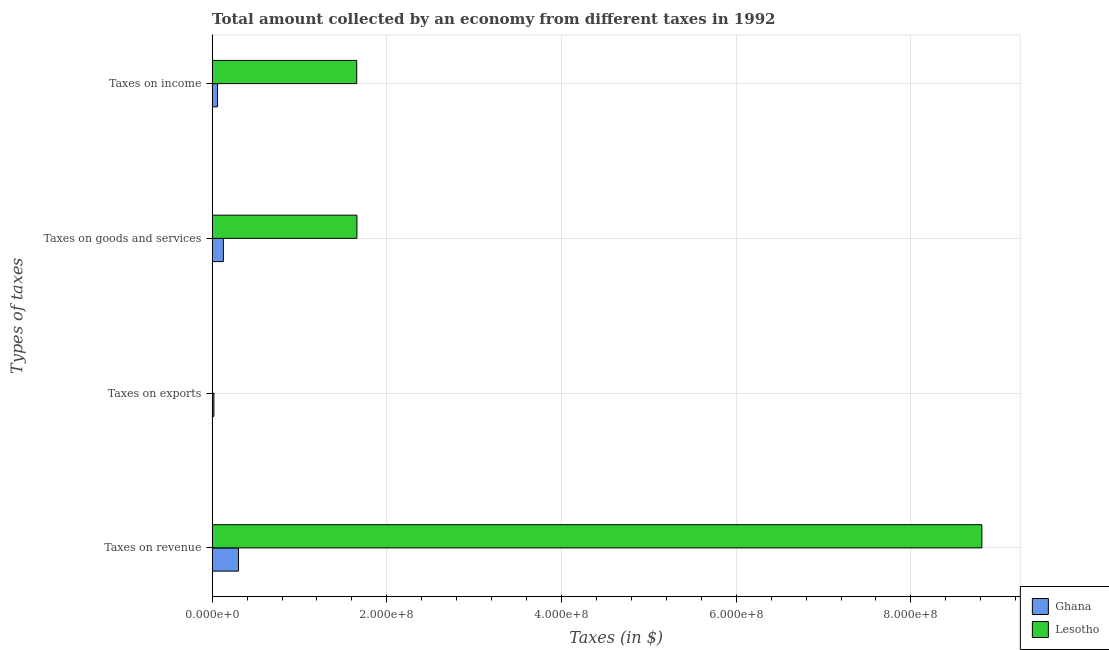How many groups of bars are there?
Your answer should be very brief. 4. Are the number of bars on each tick of the Y-axis equal?
Your answer should be compact. Yes. How many bars are there on the 1st tick from the bottom?
Provide a short and direct response. 2. What is the label of the 3rd group of bars from the top?
Your answer should be compact. Taxes on exports. What is the amount collected as tax on revenue in Ghana?
Your answer should be compact. 3.02e+07. Across all countries, what is the maximum amount collected as tax on exports?
Your response must be concise. 2.04e+06. Across all countries, what is the minimum amount collected as tax on revenue?
Keep it short and to the point. 3.02e+07. In which country was the amount collected as tax on revenue minimum?
Ensure brevity in your answer.  Ghana. What is the total amount collected as tax on income in the graph?
Offer a very short reply. 1.72e+08. What is the difference between the amount collected as tax on exports in Ghana and that in Lesotho?
Your answer should be very brief. 1.82e+06. What is the difference between the amount collected as tax on revenue in Ghana and the amount collected as tax on income in Lesotho?
Provide a short and direct response. -1.35e+08. What is the average amount collected as tax on revenue per country?
Keep it short and to the point. 4.56e+08. What is the difference between the amount collected as tax on income and amount collected as tax on exports in Ghana?
Your answer should be very brief. 4.17e+06. What is the ratio of the amount collected as tax on exports in Lesotho to that in Ghana?
Keep it short and to the point. 0.11. Is the amount collected as tax on goods in Ghana less than that in Lesotho?
Keep it short and to the point. Yes. Is the difference between the amount collected as tax on exports in Lesotho and Ghana greater than the difference between the amount collected as tax on goods in Lesotho and Ghana?
Provide a short and direct response. No. What is the difference between the highest and the second highest amount collected as tax on income?
Provide a short and direct response. 1.59e+08. What is the difference between the highest and the lowest amount collected as tax on goods?
Offer a very short reply. 1.53e+08. In how many countries, is the amount collected as tax on income greater than the average amount collected as tax on income taken over all countries?
Provide a short and direct response. 1. Is it the case that in every country, the sum of the amount collected as tax on goods and amount collected as tax on revenue is greater than the sum of amount collected as tax on exports and amount collected as tax on income?
Give a very brief answer. No. What does the 1st bar from the top in Taxes on goods and services represents?
Give a very brief answer. Lesotho. How many countries are there in the graph?
Your answer should be compact. 2. Are the values on the major ticks of X-axis written in scientific E-notation?
Give a very brief answer. Yes. Where does the legend appear in the graph?
Your answer should be compact. Bottom right. How are the legend labels stacked?
Offer a very short reply. Vertical. What is the title of the graph?
Provide a short and direct response. Total amount collected by an economy from different taxes in 1992. What is the label or title of the X-axis?
Keep it short and to the point. Taxes (in $). What is the label or title of the Y-axis?
Your answer should be very brief. Types of taxes. What is the Taxes (in $) in Ghana in Taxes on revenue?
Give a very brief answer. 3.02e+07. What is the Taxes (in $) of Lesotho in Taxes on revenue?
Your response must be concise. 8.81e+08. What is the Taxes (in $) in Ghana in Taxes on exports?
Your answer should be very brief. 2.04e+06. What is the Taxes (in $) in Lesotho in Taxes on exports?
Ensure brevity in your answer.  2.14e+05. What is the Taxes (in $) in Ghana in Taxes on goods and services?
Your answer should be very brief. 1.29e+07. What is the Taxes (in $) of Lesotho in Taxes on goods and services?
Offer a very short reply. 1.66e+08. What is the Taxes (in $) of Ghana in Taxes on income?
Keep it short and to the point. 6.21e+06. What is the Taxes (in $) in Lesotho in Taxes on income?
Make the answer very short. 1.66e+08. Across all Types of taxes, what is the maximum Taxes (in $) of Ghana?
Your answer should be compact. 3.02e+07. Across all Types of taxes, what is the maximum Taxes (in $) in Lesotho?
Provide a succinct answer. 8.81e+08. Across all Types of taxes, what is the minimum Taxes (in $) in Ghana?
Your answer should be very brief. 2.04e+06. Across all Types of taxes, what is the minimum Taxes (in $) of Lesotho?
Ensure brevity in your answer.  2.14e+05. What is the total Taxes (in $) of Ghana in the graph?
Provide a short and direct response. 5.13e+07. What is the total Taxes (in $) in Lesotho in the graph?
Make the answer very short. 1.21e+09. What is the difference between the Taxes (in $) in Ghana in Taxes on revenue and that in Taxes on exports?
Provide a short and direct response. 2.81e+07. What is the difference between the Taxes (in $) of Lesotho in Taxes on revenue and that in Taxes on exports?
Your answer should be compact. 8.81e+08. What is the difference between the Taxes (in $) of Ghana in Taxes on revenue and that in Taxes on goods and services?
Your answer should be compact. 1.73e+07. What is the difference between the Taxes (in $) in Lesotho in Taxes on revenue and that in Taxes on goods and services?
Keep it short and to the point. 7.15e+08. What is the difference between the Taxes (in $) of Ghana in Taxes on revenue and that in Taxes on income?
Provide a short and direct response. 2.40e+07. What is the difference between the Taxes (in $) of Lesotho in Taxes on revenue and that in Taxes on income?
Give a very brief answer. 7.16e+08. What is the difference between the Taxes (in $) in Ghana in Taxes on exports and that in Taxes on goods and services?
Your answer should be very brief. -1.08e+07. What is the difference between the Taxes (in $) in Lesotho in Taxes on exports and that in Taxes on goods and services?
Offer a terse response. -1.66e+08. What is the difference between the Taxes (in $) in Ghana in Taxes on exports and that in Taxes on income?
Offer a terse response. -4.17e+06. What is the difference between the Taxes (in $) of Lesotho in Taxes on exports and that in Taxes on income?
Your response must be concise. -1.65e+08. What is the difference between the Taxes (in $) of Ghana in Taxes on goods and services and that in Taxes on income?
Provide a succinct answer. 6.67e+06. What is the difference between the Taxes (in $) of Lesotho in Taxes on goods and services and that in Taxes on income?
Provide a short and direct response. 2.68e+05. What is the difference between the Taxes (in $) of Ghana in Taxes on revenue and the Taxes (in $) of Lesotho in Taxes on exports?
Provide a short and direct response. 3.00e+07. What is the difference between the Taxes (in $) of Ghana in Taxes on revenue and the Taxes (in $) of Lesotho in Taxes on goods and services?
Make the answer very short. -1.36e+08. What is the difference between the Taxes (in $) of Ghana in Taxes on revenue and the Taxes (in $) of Lesotho in Taxes on income?
Provide a short and direct response. -1.35e+08. What is the difference between the Taxes (in $) in Ghana in Taxes on exports and the Taxes (in $) in Lesotho in Taxes on goods and services?
Provide a succinct answer. -1.64e+08. What is the difference between the Taxes (in $) of Ghana in Taxes on exports and the Taxes (in $) of Lesotho in Taxes on income?
Your answer should be compact. -1.63e+08. What is the difference between the Taxes (in $) of Ghana in Taxes on goods and services and the Taxes (in $) of Lesotho in Taxes on income?
Your answer should be compact. -1.53e+08. What is the average Taxes (in $) in Ghana per Types of taxes?
Provide a short and direct response. 1.28e+07. What is the average Taxes (in $) of Lesotho per Types of taxes?
Ensure brevity in your answer.  3.03e+08. What is the difference between the Taxes (in $) in Ghana and Taxes (in $) in Lesotho in Taxes on revenue?
Ensure brevity in your answer.  -8.51e+08. What is the difference between the Taxes (in $) in Ghana and Taxes (in $) in Lesotho in Taxes on exports?
Your answer should be compact. 1.82e+06. What is the difference between the Taxes (in $) of Ghana and Taxes (in $) of Lesotho in Taxes on goods and services?
Offer a very short reply. -1.53e+08. What is the difference between the Taxes (in $) of Ghana and Taxes (in $) of Lesotho in Taxes on income?
Make the answer very short. -1.59e+08. What is the ratio of the Taxes (in $) in Ghana in Taxes on revenue to that in Taxes on exports?
Your answer should be compact. 14.82. What is the ratio of the Taxes (in $) in Lesotho in Taxes on revenue to that in Taxes on exports?
Ensure brevity in your answer.  4118.14. What is the ratio of the Taxes (in $) of Ghana in Taxes on revenue to that in Taxes on goods and services?
Offer a very short reply. 2.34. What is the ratio of the Taxes (in $) in Lesotho in Taxes on revenue to that in Taxes on goods and services?
Your answer should be very brief. 5.32. What is the ratio of the Taxes (in $) in Ghana in Taxes on revenue to that in Taxes on income?
Give a very brief answer. 4.86. What is the ratio of the Taxes (in $) in Lesotho in Taxes on revenue to that in Taxes on income?
Offer a terse response. 5.32. What is the ratio of the Taxes (in $) in Ghana in Taxes on exports to that in Taxes on goods and services?
Ensure brevity in your answer.  0.16. What is the ratio of the Taxes (in $) in Lesotho in Taxes on exports to that in Taxes on goods and services?
Offer a terse response. 0. What is the ratio of the Taxes (in $) of Ghana in Taxes on exports to that in Taxes on income?
Provide a succinct answer. 0.33. What is the ratio of the Taxes (in $) of Lesotho in Taxes on exports to that in Taxes on income?
Offer a terse response. 0. What is the ratio of the Taxes (in $) of Ghana in Taxes on goods and services to that in Taxes on income?
Keep it short and to the point. 2.07. What is the ratio of the Taxes (in $) of Lesotho in Taxes on goods and services to that in Taxes on income?
Your response must be concise. 1. What is the difference between the highest and the second highest Taxes (in $) in Ghana?
Ensure brevity in your answer.  1.73e+07. What is the difference between the highest and the second highest Taxes (in $) in Lesotho?
Offer a very short reply. 7.15e+08. What is the difference between the highest and the lowest Taxes (in $) in Ghana?
Offer a terse response. 2.81e+07. What is the difference between the highest and the lowest Taxes (in $) of Lesotho?
Provide a short and direct response. 8.81e+08. 